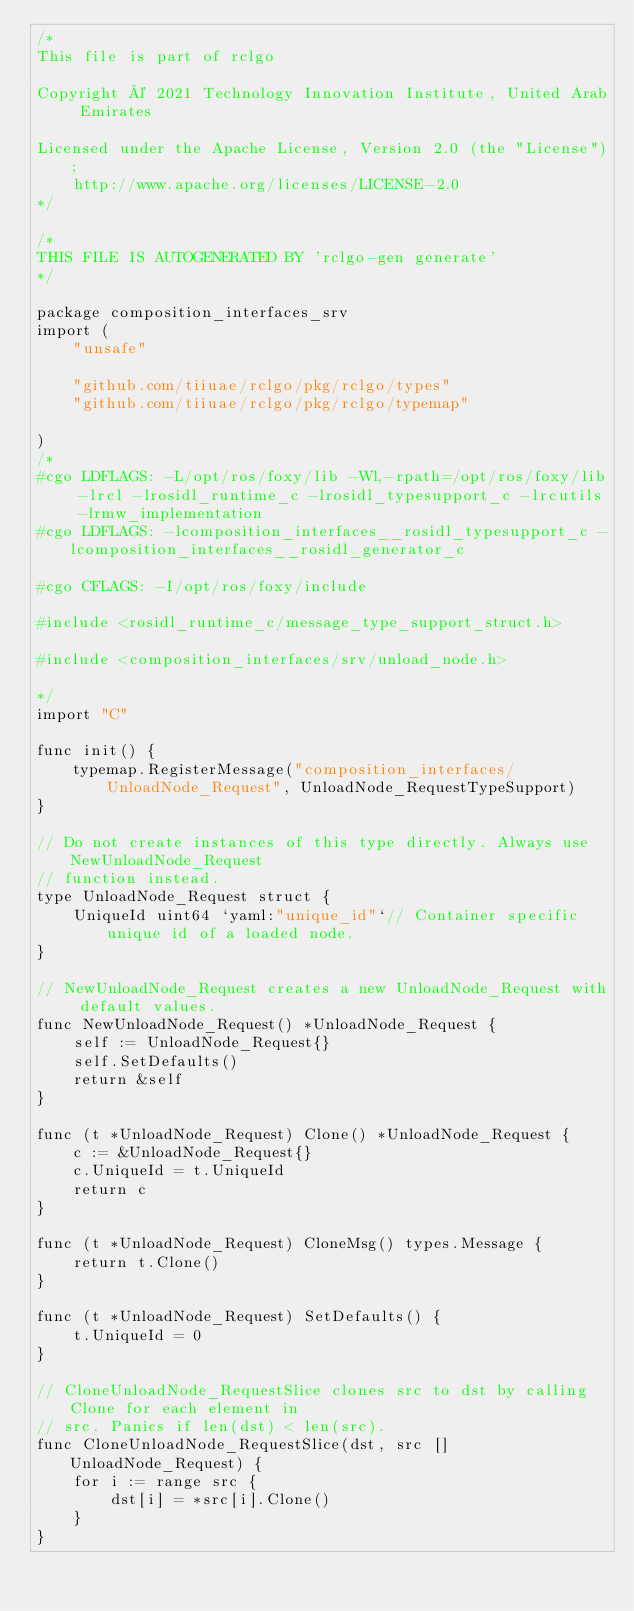<code> <loc_0><loc_0><loc_500><loc_500><_Go_>/*
This file is part of rclgo

Copyright © 2021 Technology Innovation Institute, United Arab Emirates

Licensed under the Apache License, Version 2.0 (the "License");
	http://www.apache.org/licenses/LICENSE-2.0
*/

/*
THIS FILE IS AUTOGENERATED BY 'rclgo-gen generate'
*/

package composition_interfaces_srv
import (
	"unsafe"

	"github.com/tiiuae/rclgo/pkg/rclgo/types"
	"github.com/tiiuae/rclgo/pkg/rclgo/typemap"
	
)
/*
#cgo LDFLAGS: -L/opt/ros/foxy/lib -Wl,-rpath=/opt/ros/foxy/lib -lrcl -lrosidl_runtime_c -lrosidl_typesupport_c -lrcutils -lrmw_implementation
#cgo LDFLAGS: -lcomposition_interfaces__rosidl_typesupport_c -lcomposition_interfaces__rosidl_generator_c

#cgo CFLAGS: -I/opt/ros/foxy/include

#include <rosidl_runtime_c/message_type_support_struct.h>

#include <composition_interfaces/srv/unload_node.h>

*/
import "C"

func init() {
	typemap.RegisterMessage("composition_interfaces/UnloadNode_Request", UnloadNode_RequestTypeSupport)
}

// Do not create instances of this type directly. Always use NewUnloadNode_Request
// function instead.
type UnloadNode_Request struct {
	UniqueId uint64 `yaml:"unique_id"`// Container specific unique id of a loaded node.
}

// NewUnloadNode_Request creates a new UnloadNode_Request with default values.
func NewUnloadNode_Request() *UnloadNode_Request {
	self := UnloadNode_Request{}
	self.SetDefaults()
	return &self
}

func (t *UnloadNode_Request) Clone() *UnloadNode_Request {
	c := &UnloadNode_Request{}
	c.UniqueId = t.UniqueId
	return c
}

func (t *UnloadNode_Request) CloneMsg() types.Message {
	return t.Clone()
}

func (t *UnloadNode_Request) SetDefaults() {
	t.UniqueId = 0
}

// CloneUnloadNode_RequestSlice clones src to dst by calling Clone for each element in
// src. Panics if len(dst) < len(src).
func CloneUnloadNode_RequestSlice(dst, src []UnloadNode_Request) {
	for i := range src {
		dst[i] = *src[i].Clone()
	}
}
</code> 